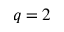Convert formula to latex. <formula><loc_0><loc_0><loc_500><loc_500>q = 2</formula> 